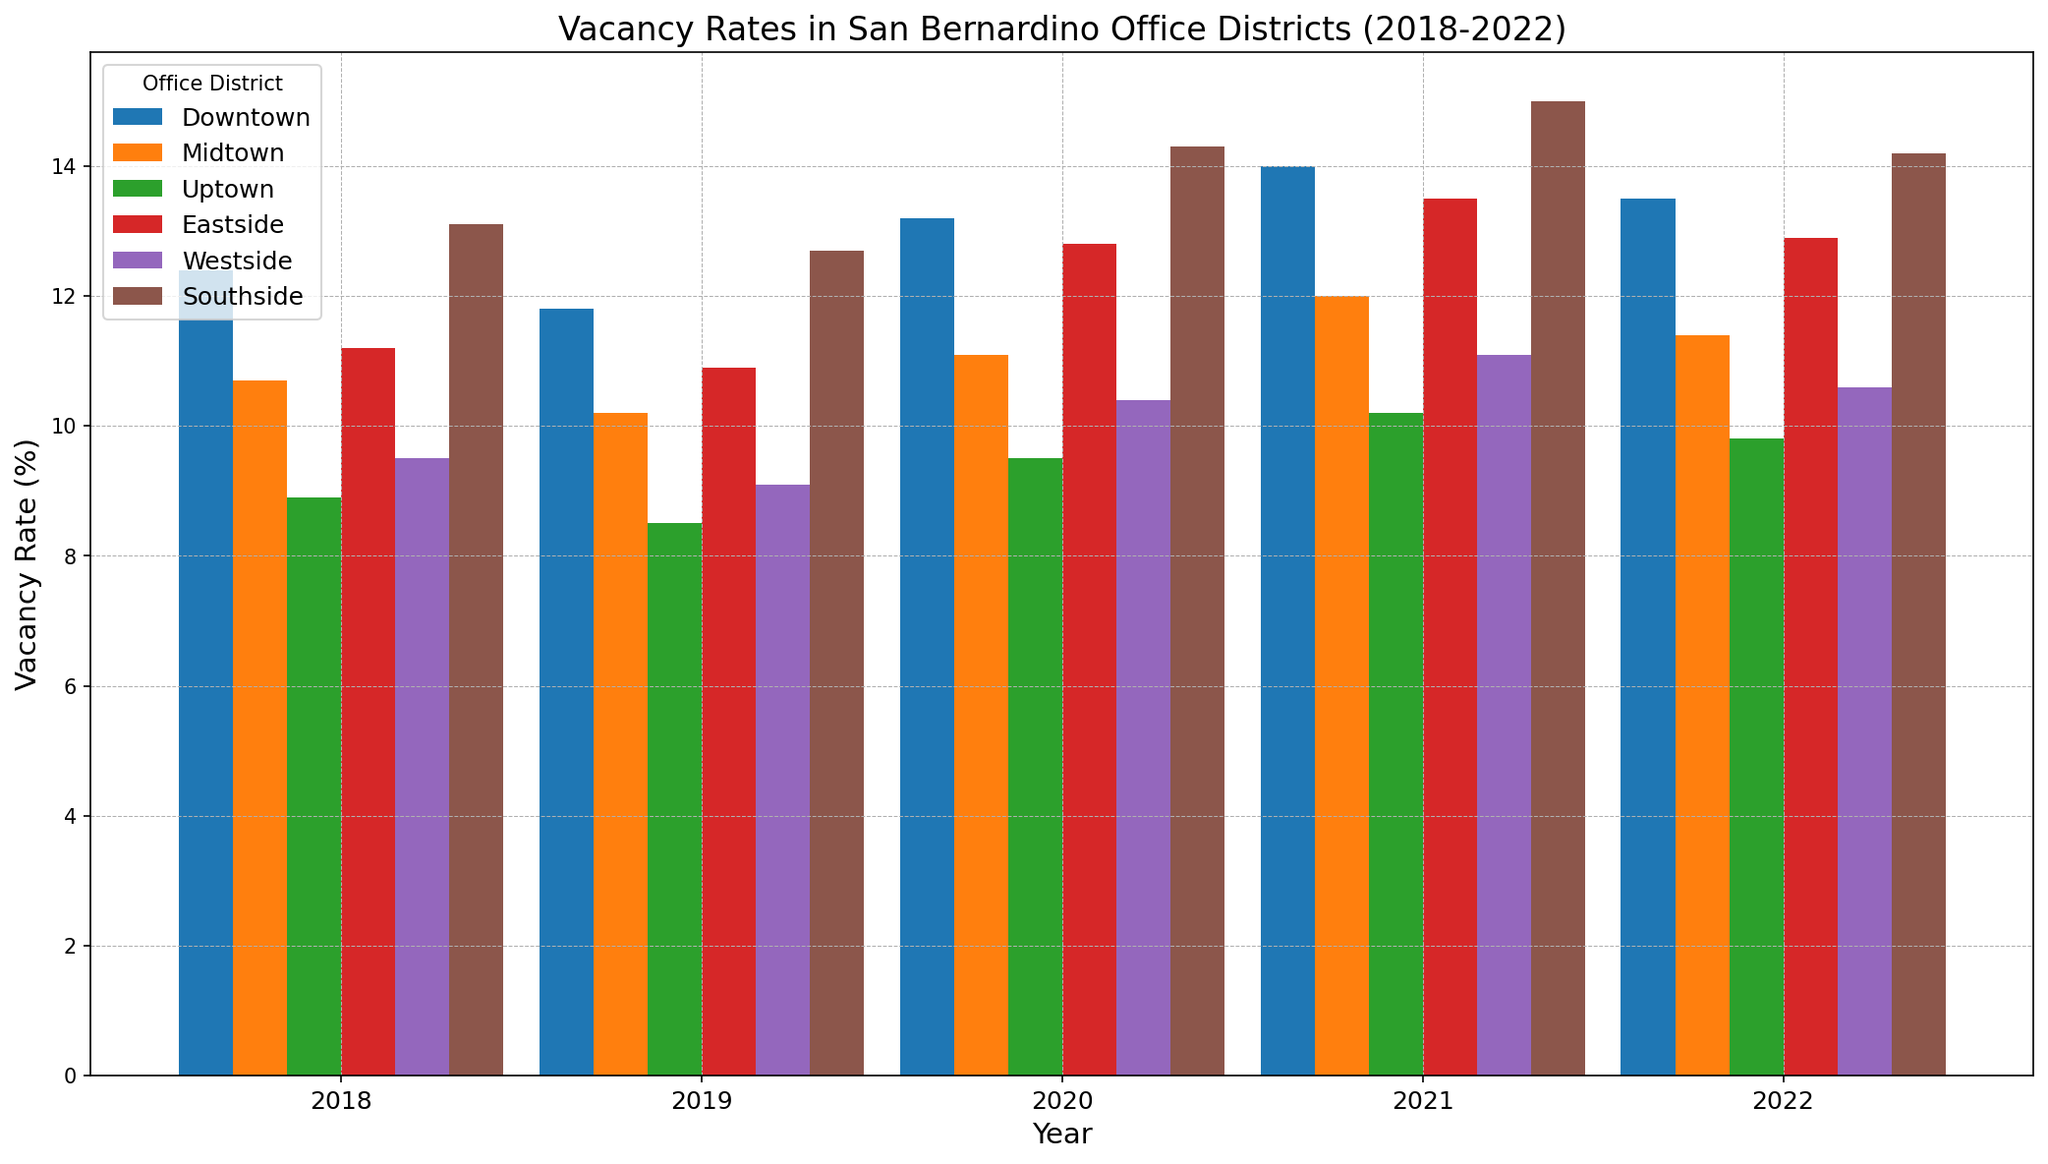Which district had the highest vacancy rate in 2021? Look at the bars for each district in 2021. The tallest bar in 2021 corresponds to the Southside district.
Answer: Southside Which district showed the largest increase in vacancy rate from 2019 to 2020? Subtract the vacancy rate of each district in 2019 from their respective rates in 2020. Southside saw the largest increase from 12.7% to 14.3%, which is a 1.6% increase.
Answer: Southside What is the average vacancy rate for the Westside district over the five years? Sum the vacancy rates for Westside over the 5 years (9.5 + 9.1 + 10.4 + 11.1 + 10.6). Divide this sum by 5. (50.7/5 = 10.14)
Answer: 10.14% Between 2020 and 2021, which two districts had their vacancy rates increase, and by how much? Compare the bars for 2020 and 2021 for each district: Downtown increased from 13.2% to 14.0% (0.8%), Midtown from 11.1% to 12.0% (0.9%).
Answer: Downtown (0.8%) and Midtown (0.9%) Which district consistently had the lowest vacancy rate each year? Look for the district with the shortest bars each year. Uptown has the lowest rates across all five years.
Answer: Uptown What was the overall trend in vacancy rates for the Eastside district from 2018 to 2022? Observe the height of the bars for Eastside from 2018 to 2022. It starts at 11.2%, dips slightly in 2019 to 10.9%, peaks at 13.5% in 2021, and drops to 12.9% in 2022.
Answer: Generally increasing with a peak in 2021 How did the vacancy rate in Downtown change from 2018 to 2022? Subtract the 2018 rate from the 2022 rate for Downtown. It decreases from 12.4% to 11.8% in 2019, rises to 13.2% in 2020, peaks at 14.0% in 2021, and slightly drops to 13.5% in 2022. Overall 13.5% - 12.4%.
Answer: Increased by 1.1% Comparing Midtown and Southside in 2021, which district had a higher vacancy rate and by how much? Check the heights of Midtown and Southside bars in 2021. Midtown was 12.0% whereas Southside was 15.0%. The difference is 15.0% - 12.0%.
Answer: Southside by 3.0% 